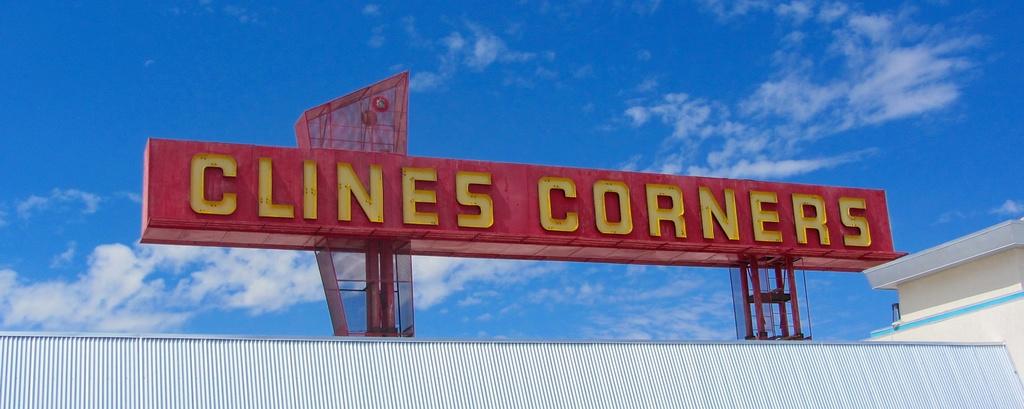What is the name of this place?
Keep it short and to the point. Clines corners. 